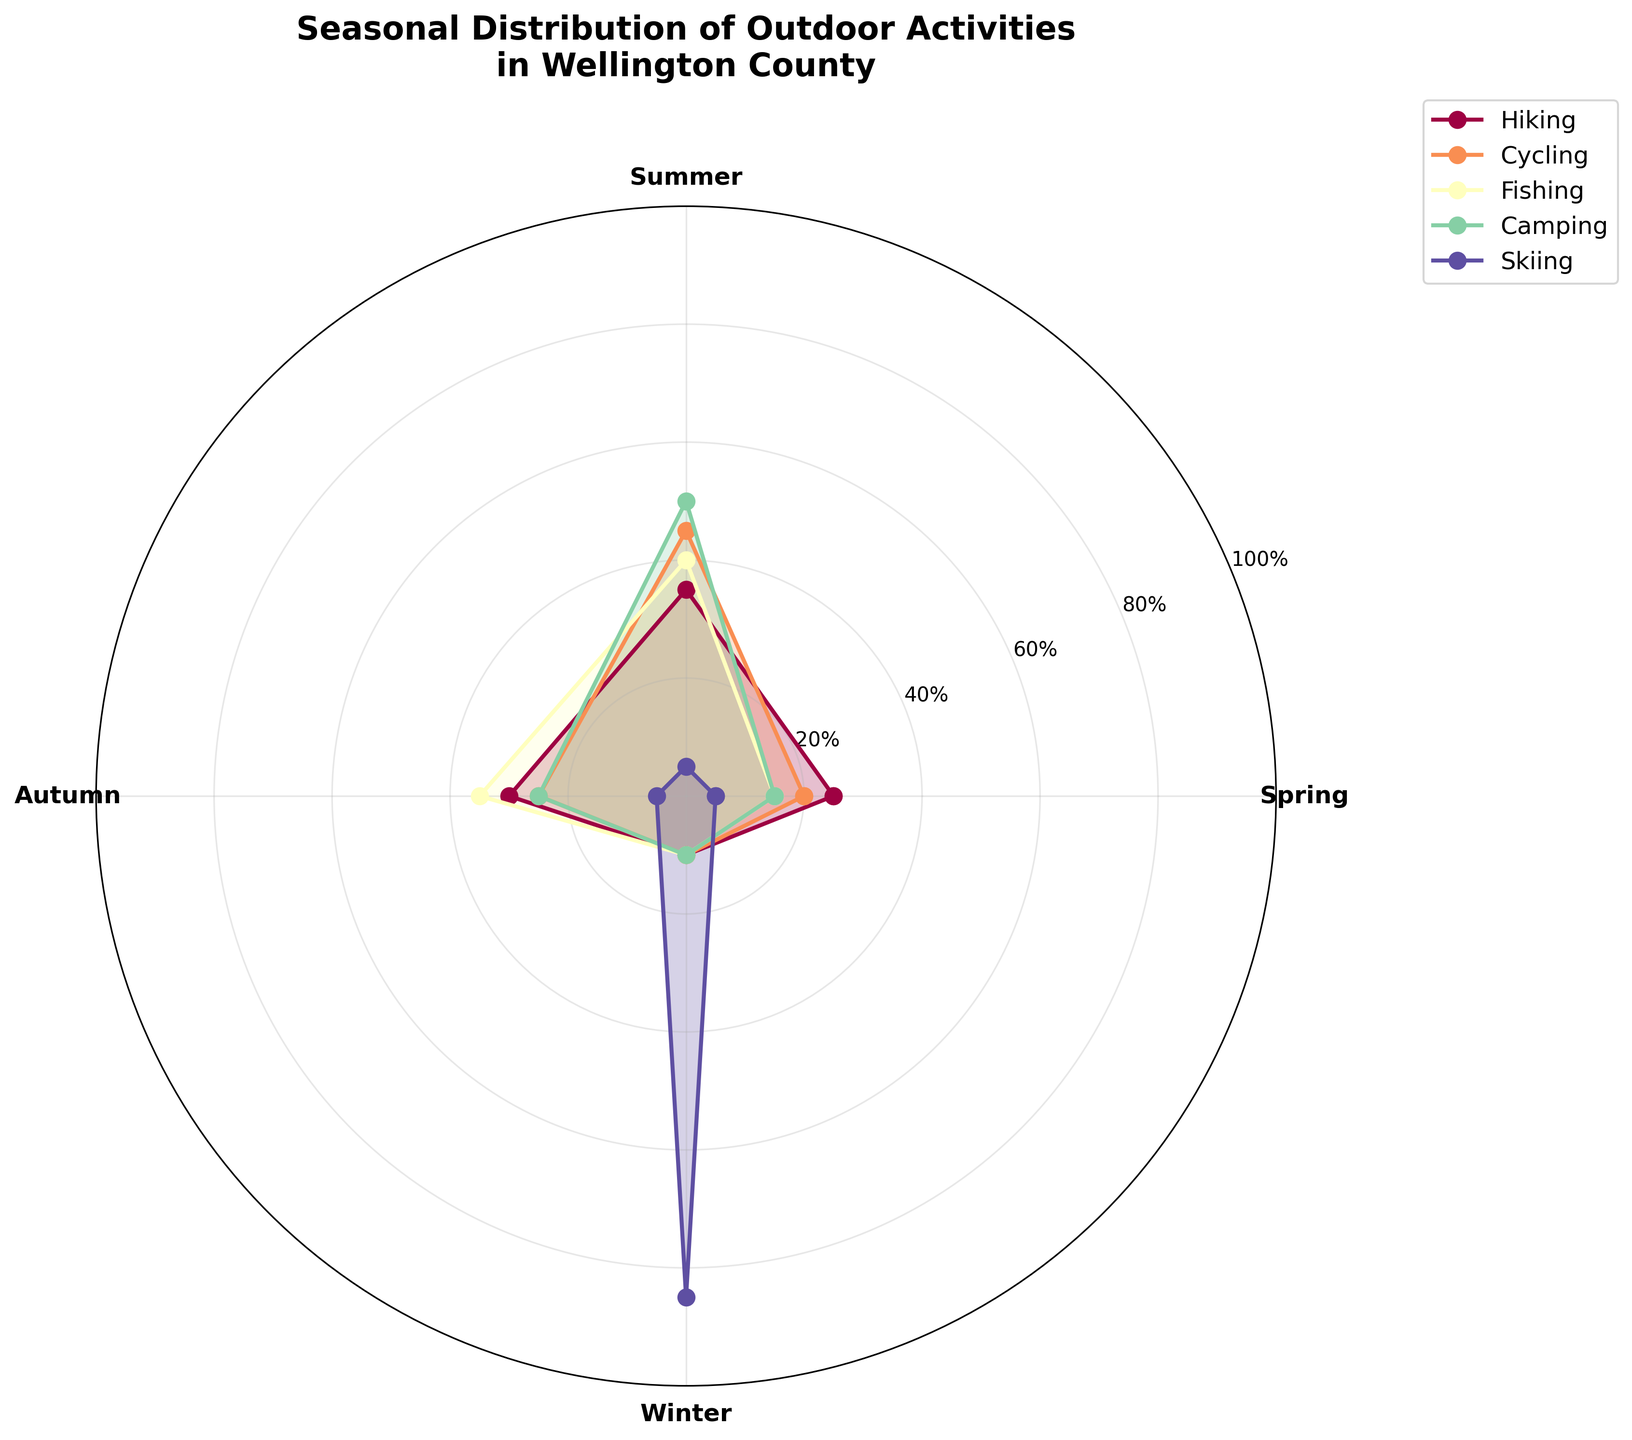Which activity has the highest participation percentage in the summer? To determine this, look at all activities' participation percentages for the summer. The activity with the highest percentage is the one with the highest bar in the summer section.
Answer: Camping What is the approximate difference in participation percentage between hiking and cycling in autumn? Identify the participation percentages for hiking (30%) and cycling (25%) in autumn. Subtract the lower percentage from the higher percentage (30% - 25% = 5%).
Answer: 5% During which season is skiing most popular? Look for the season where skiing has the highest participation percentage. This can be identified by the tallest segment for skiing, which occurs in winter.
Answer: Winter What total participation percentage does fishing have if you sum the values for all seasons? Add the participation percentages for fishing in all seasons: Spring (15%), Summer (40%), Autumn (35%), and Winter (10%). Summing them: 15% + 40% + 35% + 10% = 100%.
Answer: 100% Compare the participation percentages of hiking between spring and autumn. Which is higher and by how much? The participation percentages for hiking are 25% in spring and 30% in autumn. Autumn has a higher participation by 5%.
Answer: Autumn, by 5% Which activities have the same participation percentage in winter? Examine the winter season segment for each activity. Identify the activities that have the same percentage. Both hiking, cycling, fishing, and camping have 10% participation in winter.
Answer: Hiking, cycling, fishing, camping What is the average participation percentage for all activities in spring? Sum the participation percentages for all activities in spring: Hiking (25%), Cycling (20%), Fishing (15%), Camping (15%), and Skiing (5%). Divide by the number of activities: (25 + 20 + 15 + 15 + 5) / 5 = 80% / 5 = 16%.
Answer: 16% During which season do we see the smallest participation percentages for skiing, and what are these percentages? Identify the participation percentages for skiing in all seasons. Spring, Summer, and Autumn each have 5%, which are the smallest values and they are equal.
Answer: Spring, Summer, Autumn; 5% What percentage of the years' hiking participation happens during summer and autumn combined? Find the participation percentages for hiking in summer (35%) and autumn (30%), then sum these two values: 35% + 30% = 65%.
Answer: 65% Considering all activities, which season shows the highest combined participation percentage? Sum the participation percentages for all activities in each season: Spring (25+20+15+15+5=80), Summer (35+45+40+50+5=175), Autumn (30+25+35+25+5=120), Winter (10+10+10+10+85=125). Summer has the highest combined percentage (175%).
Answer: Summer 